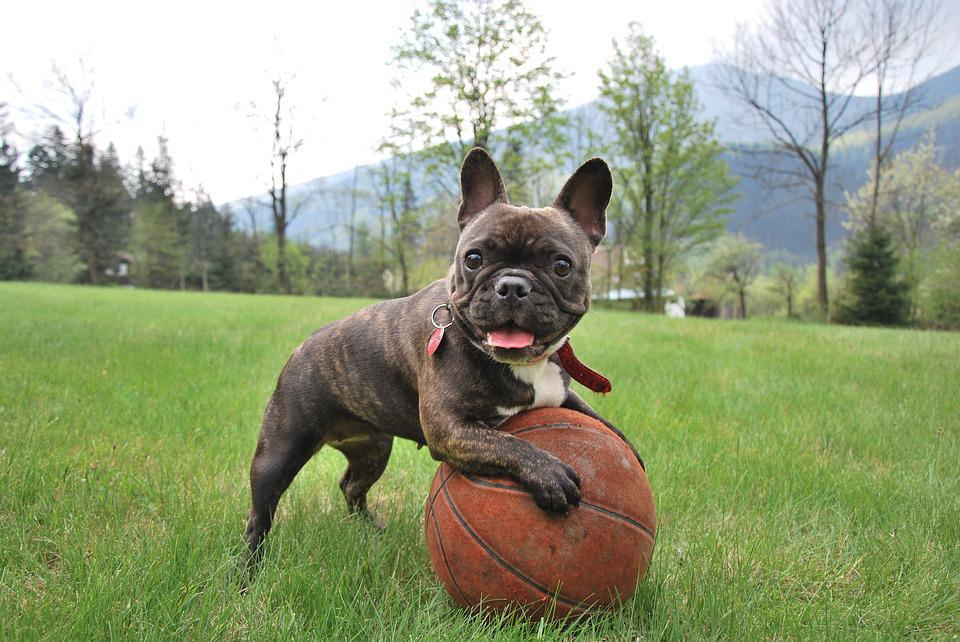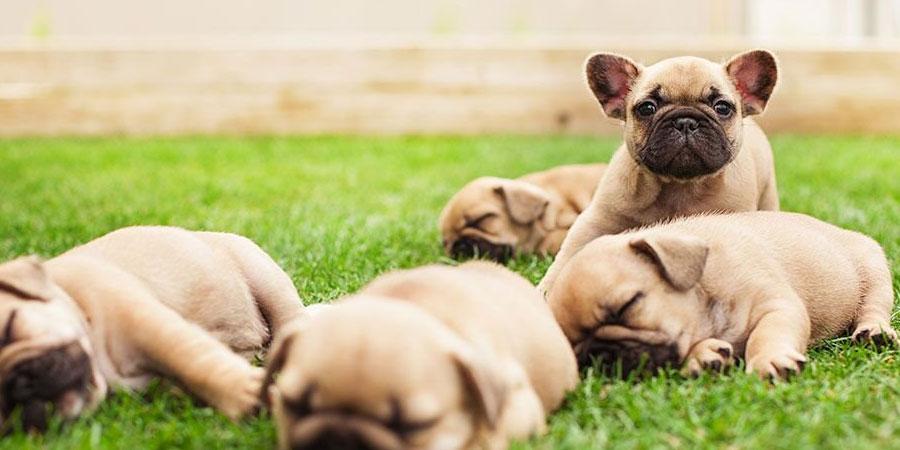The first image is the image on the left, the second image is the image on the right. Evaluate the accuracy of this statement regarding the images: "Left image shows one tan-colored dog posed in the grass, with body turned rightward.". Is it true? Answer yes or no. No. The first image is the image on the left, the second image is the image on the right. Given the left and right images, does the statement "There is a bulldog with a small white patch of fur on his chest and all four of his feet are in the grass." hold true? Answer yes or no. No. 